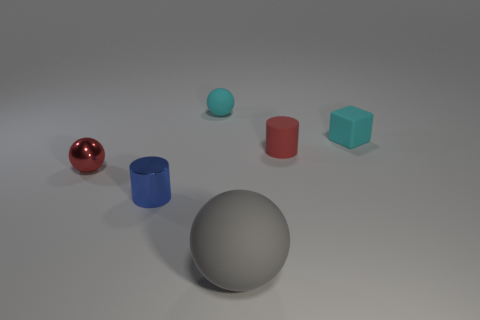Are the tiny cyan cube and the blue thing made of the same material?
Offer a terse response. No. Are there any matte spheres in front of the tiny shiny cylinder?
Offer a very short reply. Yes. What is the material of the small object that is behind the cyan rubber object right of the large gray ball?
Offer a very short reply. Rubber. What is the size of the cyan thing that is the same shape as the gray object?
Make the answer very short. Small. Is the color of the matte cylinder the same as the small metallic cylinder?
Make the answer very short. No. What is the color of the thing that is both in front of the tiny red sphere and on the right side of the blue cylinder?
Offer a terse response. Gray. There is a gray thing that is to the left of the matte cylinder; is it the same size as the tiny red metal thing?
Give a very brief answer. No. Are there any other things that have the same shape as the blue thing?
Offer a very short reply. Yes. Is the material of the tiny cyan ball the same as the red object left of the large gray ball?
Offer a terse response. No. How many red things are spheres or blocks?
Your answer should be very brief. 1. 